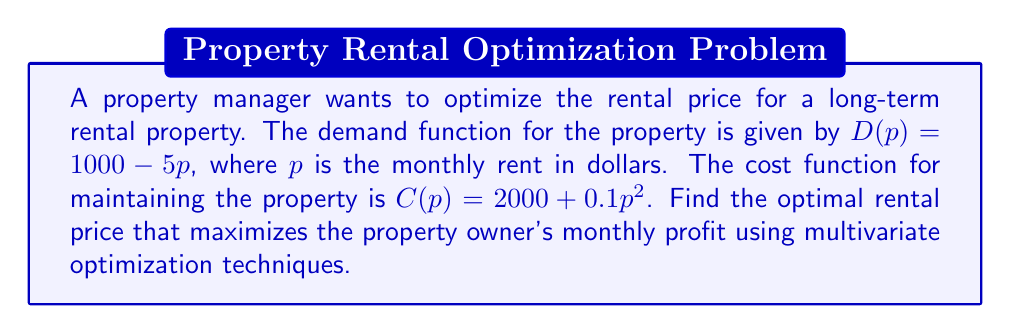Could you help me with this problem? To solve this problem, we'll use the following steps:

1) Define the profit function:
   Profit = Revenue - Cost
   $\Pi(p) = pD(p) - C(p)$

2) Substitute the given functions:
   $\Pi(p) = p(1000 - 5p) - (2000 + 0.1p^2)$
   $\Pi(p) = 1000p - 5p^2 - 2000 - 0.1p^2$
   $\Pi(p) = 1000p - 5.1p^2 - 2000$

3) To find the maximum profit, we need to find the critical point where the derivative of the profit function is zero:
   $\frac{d\Pi}{dp} = 1000 - 10.2p$

4) Set the derivative to zero and solve for p:
   $1000 - 10.2p = 0$
   $10.2p = 1000$
   $p = \frac{1000}{10.2} \approx 98.04$

5) To confirm this is a maximum, we check the second derivative:
   $\frac{d^2\Pi}{dp^2} = -10.2$

   Since the second derivative is negative, this critical point is indeed a maximum.

6) Round the result to the nearest dollar for practical application.
Answer: $98 